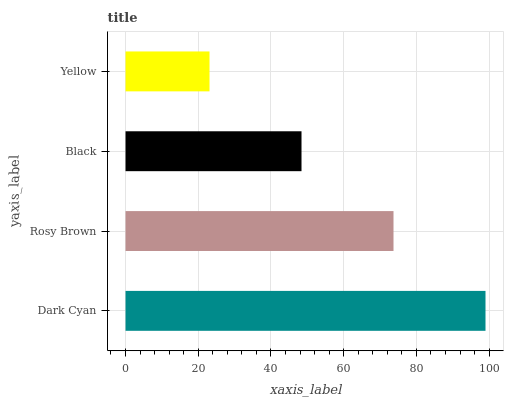Is Yellow the minimum?
Answer yes or no. Yes. Is Dark Cyan the maximum?
Answer yes or no. Yes. Is Rosy Brown the minimum?
Answer yes or no. No. Is Rosy Brown the maximum?
Answer yes or no. No. Is Dark Cyan greater than Rosy Brown?
Answer yes or no. Yes. Is Rosy Brown less than Dark Cyan?
Answer yes or no. Yes. Is Rosy Brown greater than Dark Cyan?
Answer yes or no. No. Is Dark Cyan less than Rosy Brown?
Answer yes or no. No. Is Rosy Brown the high median?
Answer yes or no. Yes. Is Black the low median?
Answer yes or no. Yes. Is Dark Cyan the high median?
Answer yes or no. No. Is Yellow the low median?
Answer yes or no. No. 